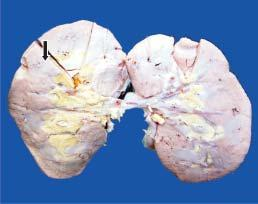what is small and pale in colour?
Answer the question using a single word or phrase. The kidney 